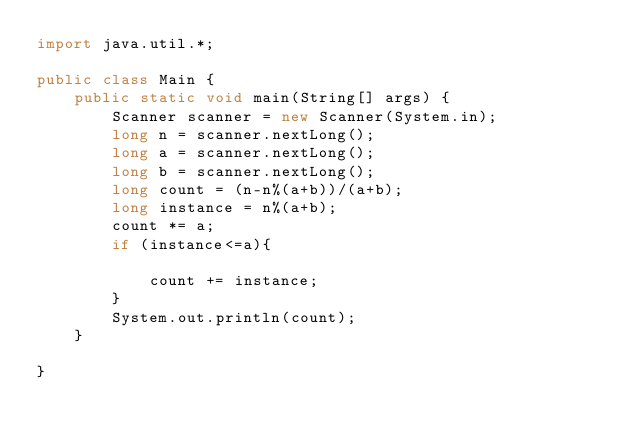Convert code to text. <code><loc_0><loc_0><loc_500><loc_500><_Java_>import java.util.*;

public class Main {
    public static void main(String[] args) {
        Scanner scanner = new Scanner(System.in);
        long n = scanner.nextLong();
        long a = scanner.nextLong();
        long b = scanner.nextLong();
        long count = (n-n%(a+b))/(a+b);
        long instance = n%(a+b);
        count *= a;
        if (instance<=a){

            count += instance;
        }
        System.out.println(count);
    }

}</code> 